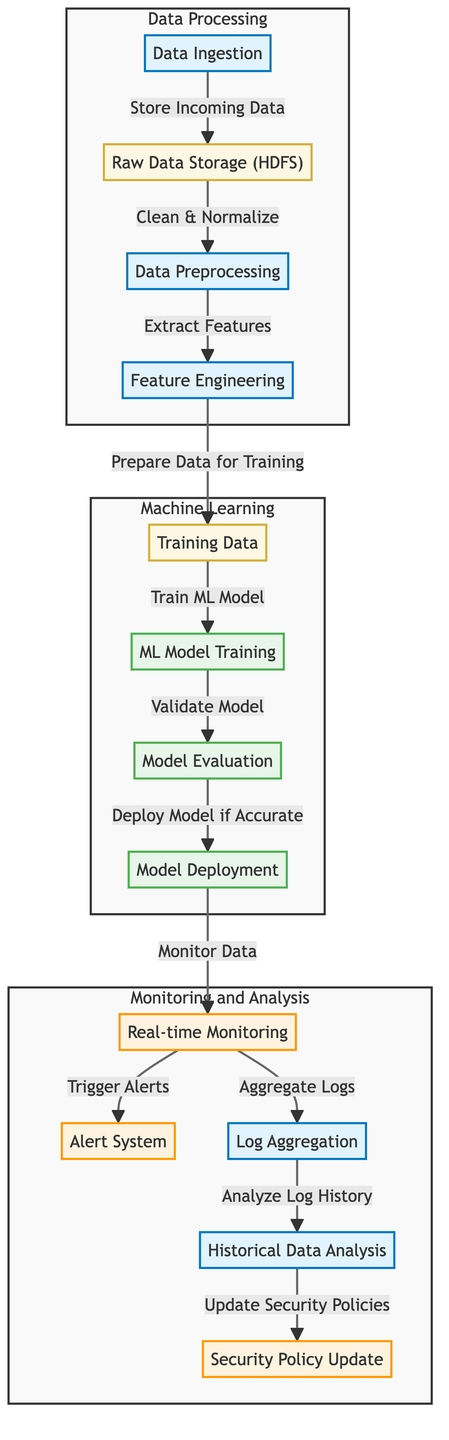What is the first step in the process? The diagram starts with "Data Ingestion" as the first step. This is the first node through which incoming data flows into the system.
Answer: Data Ingestion How many processes are shown in the diagram? The diagram has a total of five process nodes: Data Ingestion, Data Preprocessing, Feature Engineering, ML Model Training, and Log Aggregation. By counting all the nodes categorized as processes, we arrive at this number.
Answer: Five Which node comes after model evaluation? Following "Model Evaluation," the next node in the flow is "Model Deployment," where the validated model is deployed for use.
Answer: Model Deployment What is the purpose of the alert system? The "Alert System" receives triggers from "Real-time Monitoring," indicating its role in alerting users about detected anomalies or breaches in security.
Answer: Trigger Alerts How many subgraphs are present in the diagram? The diagram consists of three subgraphs: Data Processing, Machine Learning, and Monitoring and Analysis. Each subgraph organizes related nodes.
Answer: Three What process directly leads to training data? "Feature Engineering" prepares the data for training, which is the direct step leading to "Training Data." This indicates that feature extraction is essential before training the model.
Answer: Prepare Data for Training Which node indicates where raw data is stored? The node "Raw Data Storage (HDFS)" indicates where the incoming raw data is stored after ingestion. This information is directly conveyed in the diagram's flow.
Answer: Raw Data Storage (HDFS) What action follows 'Real-time Monitoring'? After "Real-time Monitoring," the diagram shows that data is either sent to the "Alert System" or "Log Aggregation," indicating it's responsible for triggering alerts and aggregating logs. Both actions follow this monitoring step.
Answer: Aggregate Logs What is the last step shown in the diagram? The final step shown in the diagram is "Security Policy Update," which comes after "Historical Data Analysis" and indicates an action taken based on analyzed log history.
Answer: Security Policy Update 